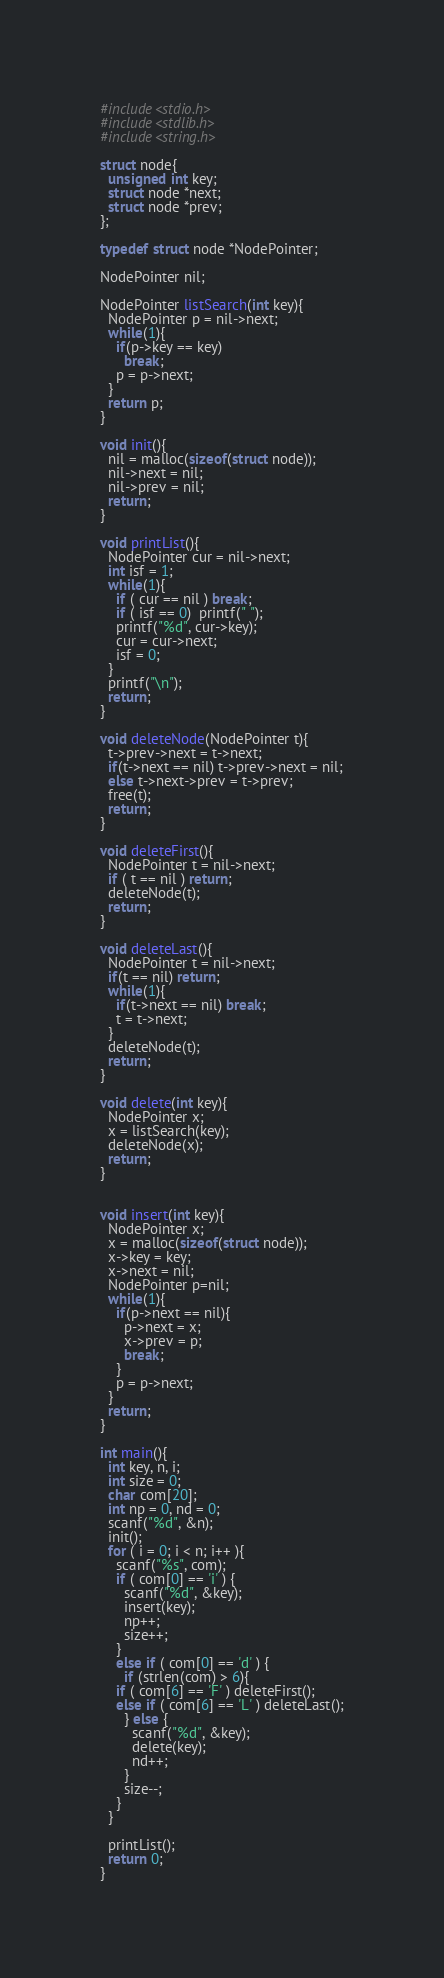Convert code to text. <code><loc_0><loc_0><loc_500><loc_500><_C_>#include<stdio.h>
#include<stdlib.h>
#include<string.h>

struct node{
  unsigned int key;
  struct node *next;
  struct node *prev;
};

typedef struct node *NodePointer;

NodePointer nil;

NodePointer listSearch(int key){
  NodePointer p = nil->next;
  while(1){
    if(p->key == key)
      break;
    p = p->next;
  }
  return p;
}

void init(){
  nil = malloc(sizeof(struct node));
  nil->next = nil;
  nil->prev = nil;
  return;
}

void printList(){
  NodePointer cur = nil->next;
  int isf = 1;
  while(1){
    if ( cur == nil ) break;
    if ( isf == 0)  printf(" ");
    printf("%d", cur->key);
    cur = cur->next;
    isf = 0;
  }
  printf("\n");
  return;
}

void deleteNode(NodePointer t){
  t->prev->next = t->next;
  if(t->next == nil) t->prev->next = nil;
  else t->next->prev = t->prev;
  free(t);
  return;  
}

void deleteFirst(){
  NodePointer t = nil->next;
  if ( t == nil ) return;
  deleteNode(t);
  return;
}

void deleteLast(){
  NodePointer t = nil->next;
  if(t == nil) return;
  while(1){
    if(t->next == nil) break;
    t = t->next;
  }
  deleteNode(t);
  return;
}

void delete(int key){
  NodePointer x;
  x = listSearch(key);
  deleteNode(x);
  return;
}


void insert(int key){
  NodePointer x;
  x = malloc(sizeof(struct node));
  x->key = key;
  x->next = nil;
  NodePointer p=nil;
  while(1){
    if(p->next == nil){
      p->next = x;
      x->prev = p;
      break;
    }
    p = p->next;
  }
  return;
}

int main(){
  int key, n, i;
  int size = 0;
  char com[20];
  int np = 0, nd = 0;
  scanf("%d", &n);
  init();
  for ( i = 0; i < n; i++ ){
    scanf("%s", com);
    if ( com[0] == 'i' ) {
      scanf("%d", &key);
      insert(key);
      np++;
      size++;
    }
    else if ( com[0] == 'd' ) {
      if (strlen(com) > 6){
	if ( com[6] == 'F' ) deleteFirst();
	else if ( com[6] == 'L' ) deleteLast();
      } else {
        scanf("%d", &key);
        delete(key);
        nd++; 
      }
      size--;
    } 
  } 

  printList();
  return 0;
}</code> 